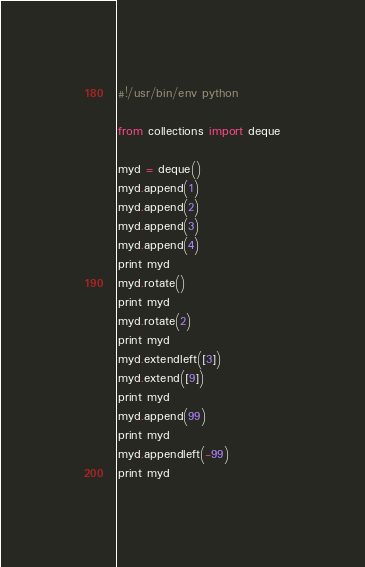<code> <loc_0><loc_0><loc_500><loc_500><_Python_>#!/usr/bin/env python

from collections import deque

myd = deque()
myd.append(1)
myd.append(2)
myd.append(3)
myd.append(4)
print myd
myd.rotate()
print myd
myd.rotate(2)
print myd
myd.extendleft([3])
myd.extend([9])
print myd
myd.append(99)
print myd
myd.appendleft(-99)
print myd
</code> 